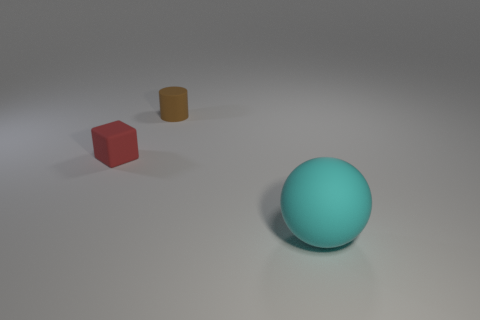Subtract all spheres. How many objects are left? 2 Subtract all green cylinders. Subtract all purple balls. How many cylinders are left? 1 Subtract all large matte objects. Subtract all cyan balls. How many objects are left? 1 Add 1 large cyan rubber things. How many large cyan rubber things are left? 2 Add 2 tiny red metal spheres. How many tiny red metal spheres exist? 2 Add 2 red rubber blocks. How many objects exist? 5 Subtract 0 blue balls. How many objects are left? 3 Subtract 1 spheres. How many spheres are left? 0 